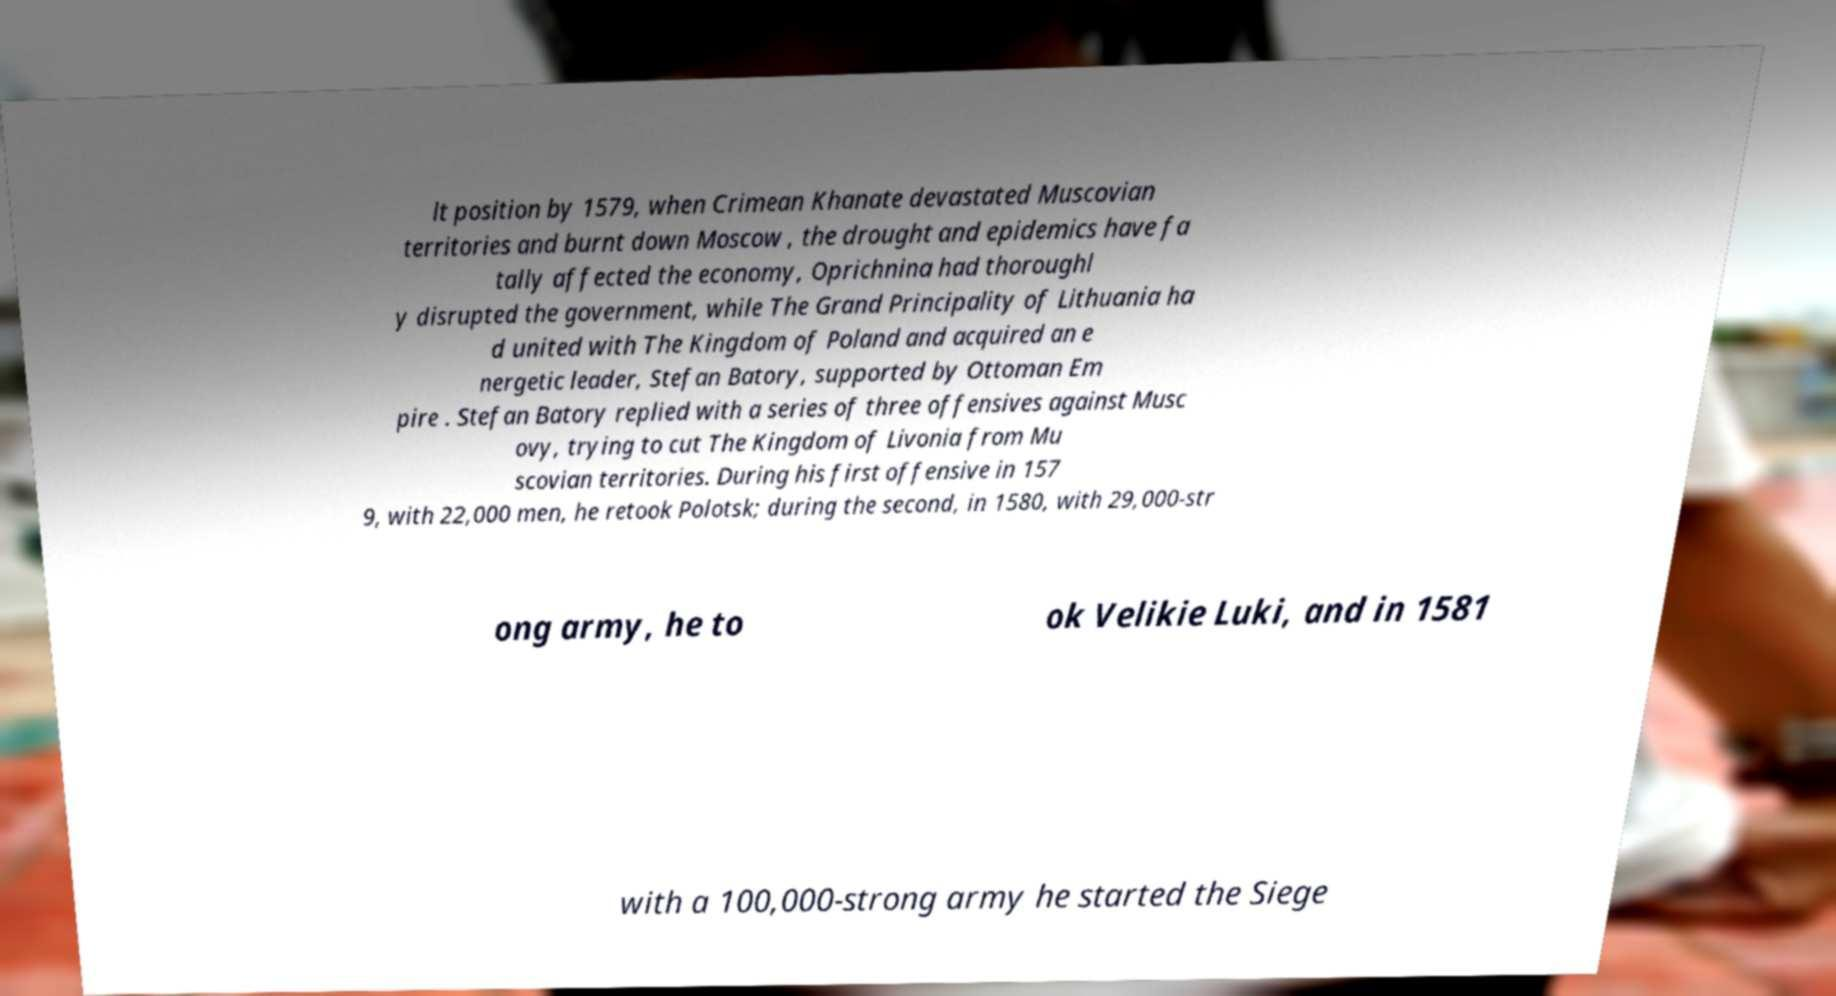Please read and relay the text visible in this image. What does it say? lt position by 1579, when Crimean Khanate devastated Muscovian territories and burnt down Moscow , the drought and epidemics have fa tally affected the economy, Oprichnina had thoroughl y disrupted the government, while The Grand Principality of Lithuania ha d united with The Kingdom of Poland and acquired an e nergetic leader, Stefan Batory, supported by Ottoman Em pire . Stefan Batory replied with a series of three offensives against Musc ovy, trying to cut The Kingdom of Livonia from Mu scovian territories. During his first offensive in 157 9, with 22,000 men, he retook Polotsk; during the second, in 1580, with 29,000-str ong army, he to ok Velikie Luki, and in 1581 with a 100,000-strong army he started the Siege 